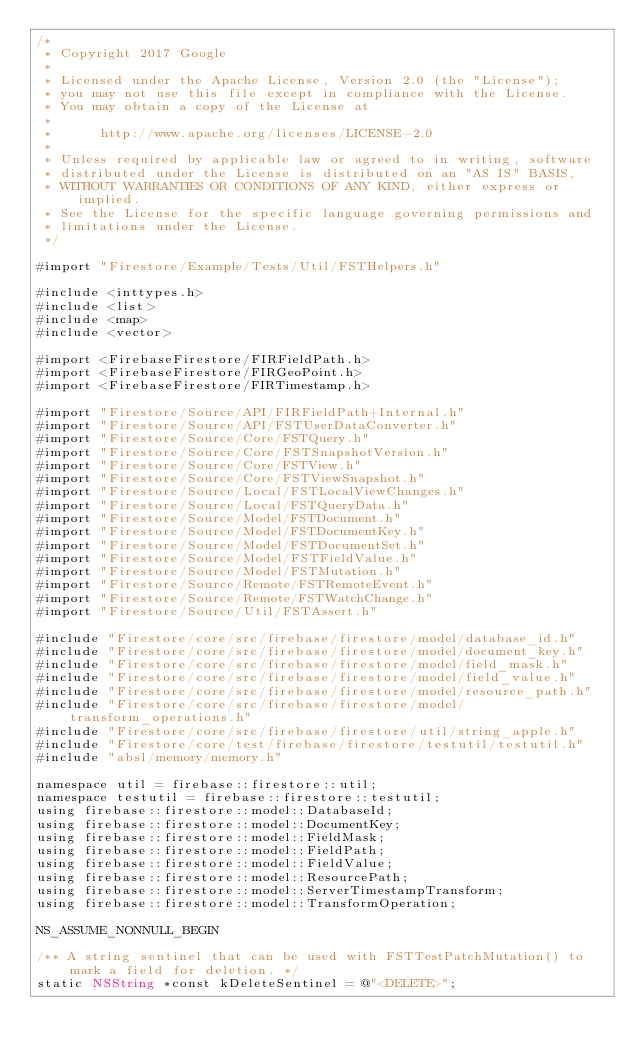Convert code to text. <code><loc_0><loc_0><loc_500><loc_500><_ObjectiveC_>/*
 * Copyright 2017 Google
 *
 * Licensed under the Apache License, Version 2.0 (the "License");
 * you may not use this file except in compliance with the License.
 * You may obtain a copy of the License at
 *
 *      http://www.apache.org/licenses/LICENSE-2.0
 *
 * Unless required by applicable law or agreed to in writing, software
 * distributed under the License is distributed on an "AS IS" BASIS,
 * WITHOUT WARRANTIES OR CONDITIONS OF ANY KIND, either express or implied.
 * See the License for the specific language governing permissions and
 * limitations under the License.
 */

#import "Firestore/Example/Tests/Util/FSTHelpers.h"

#include <inttypes.h>
#include <list>
#include <map>
#include <vector>

#import <FirebaseFirestore/FIRFieldPath.h>
#import <FirebaseFirestore/FIRGeoPoint.h>
#import <FirebaseFirestore/FIRTimestamp.h>

#import "Firestore/Source/API/FIRFieldPath+Internal.h"
#import "Firestore/Source/API/FSTUserDataConverter.h"
#import "Firestore/Source/Core/FSTQuery.h"
#import "Firestore/Source/Core/FSTSnapshotVersion.h"
#import "Firestore/Source/Core/FSTView.h"
#import "Firestore/Source/Core/FSTViewSnapshot.h"
#import "Firestore/Source/Local/FSTLocalViewChanges.h"
#import "Firestore/Source/Local/FSTQueryData.h"
#import "Firestore/Source/Model/FSTDocument.h"
#import "Firestore/Source/Model/FSTDocumentKey.h"
#import "Firestore/Source/Model/FSTDocumentSet.h"
#import "Firestore/Source/Model/FSTFieldValue.h"
#import "Firestore/Source/Model/FSTMutation.h"
#import "Firestore/Source/Remote/FSTRemoteEvent.h"
#import "Firestore/Source/Remote/FSTWatchChange.h"
#import "Firestore/Source/Util/FSTAssert.h"

#include "Firestore/core/src/firebase/firestore/model/database_id.h"
#include "Firestore/core/src/firebase/firestore/model/document_key.h"
#include "Firestore/core/src/firebase/firestore/model/field_mask.h"
#include "Firestore/core/src/firebase/firestore/model/field_value.h"
#include "Firestore/core/src/firebase/firestore/model/resource_path.h"
#include "Firestore/core/src/firebase/firestore/model/transform_operations.h"
#include "Firestore/core/src/firebase/firestore/util/string_apple.h"
#include "Firestore/core/test/firebase/firestore/testutil/testutil.h"
#include "absl/memory/memory.h"

namespace util = firebase::firestore::util;
namespace testutil = firebase::firestore::testutil;
using firebase::firestore::model::DatabaseId;
using firebase::firestore::model::DocumentKey;
using firebase::firestore::model::FieldMask;
using firebase::firestore::model::FieldPath;
using firebase::firestore::model::FieldValue;
using firebase::firestore::model::ResourcePath;
using firebase::firestore::model::ServerTimestampTransform;
using firebase::firestore::model::TransformOperation;

NS_ASSUME_NONNULL_BEGIN

/** A string sentinel that can be used with FSTTestPatchMutation() to mark a field for deletion. */
static NSString *const kDeleteSentinel = @"<DELETE>";
</code> 